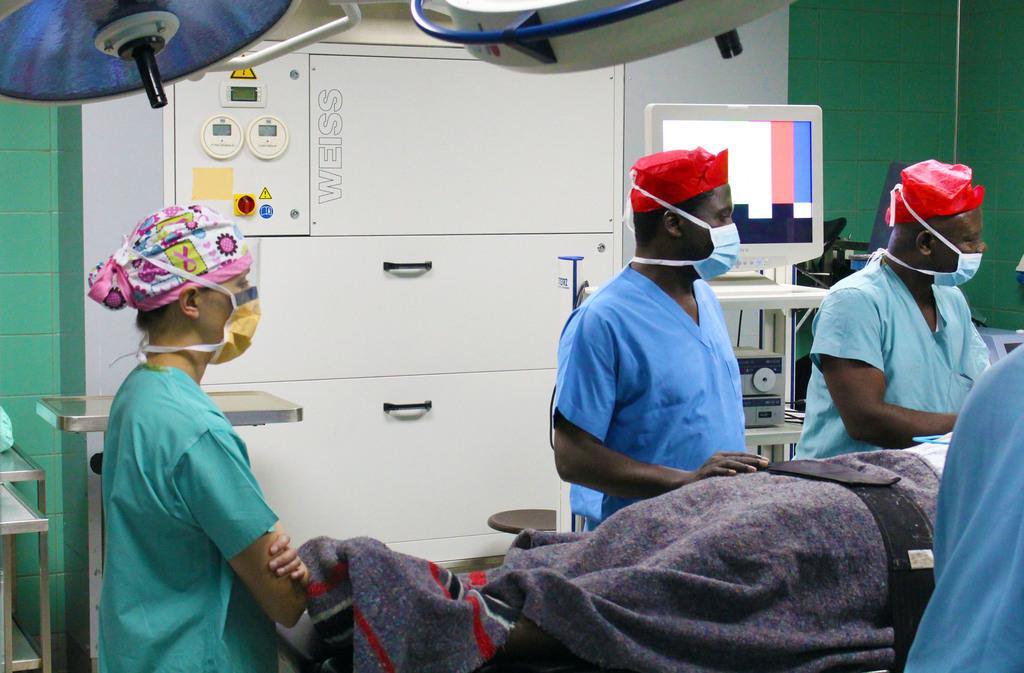In one or two sentences, can you explain what this image depicts? There are some persons standing in the middle and wearing a mask and some caps. There is a wooden shelf in the background. There are some tables on the left side of this image and there is one monitor on the right side of this image. 